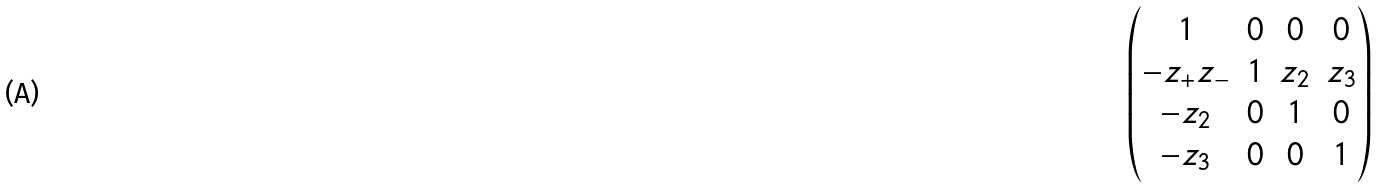Convert formula to latex. <formula><loc_0><loc_0><loc_500><loc_500>\begin{pmatrix} 1 & 0 & 0 & 0 \\ - z _ { + } z _ { - } & 1 & z _ { 2 } & z _ { 3 } \\ - z _ { 2 } & 0 & 1 & 0 \\ - z _ { 3 } & 0 & 0 & 1 \end{pmatrix}</formula> 